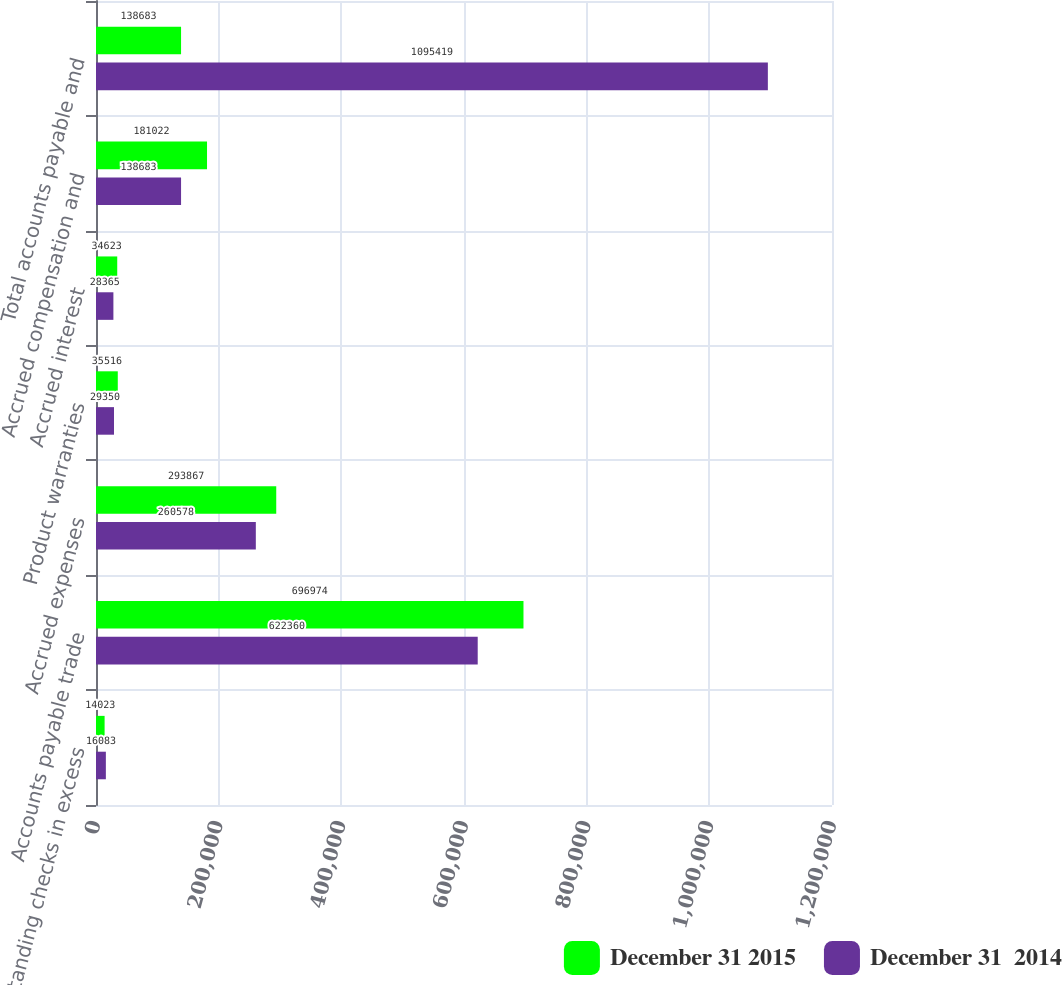Convert chart. <chart><loc_0><loc_0><loc_500><loc_500><stacked_bar_chart><ecel><fcel>Outstanding checks in excess<fcel>Accounts payable trade<fcel>Accrued expenses<fcel>Product warranties<fcel>Accrued interest<fcel>Accrued compensation and<fcel>Total accounts payable and<nl><fcel>December 31 2015<fcel>14023<fcel>696974<fcel>293867<fcel>35516<fcel>34623<fcel>181022<fcel>138683<nl><fcel>December 31  2014<fcel>16083<fcel>622360<fcel>260578<fcel>29350<fcel>28365<fcel>138683<fcel>1.09542e+06<nl></chart> 